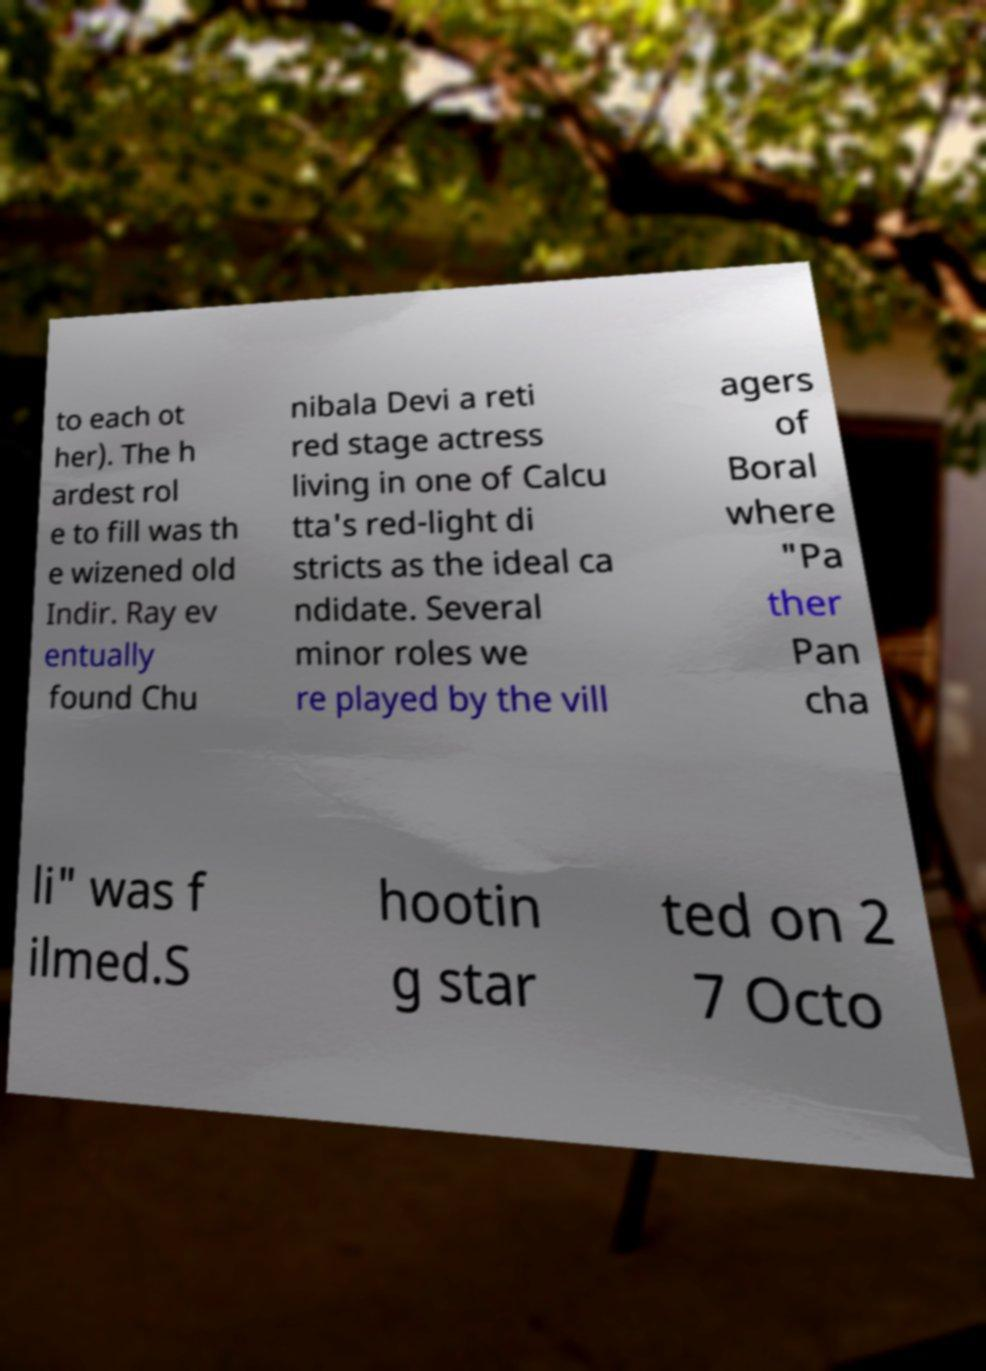Could you extract and type out the text from this image? to each ot her). The h ardest rol e to fill was th e wizened old Indir. Ray ev entually found Chu nibala Devi a reti red stage actress living in one of Calcu tta's red-light di stricts as the ideal ca ndidate. Several minor roles we re played by the vill agers of Boral where "Pa ther Pan cha li" was f ilmed.S hootin g star ted on 2 7 Octo 